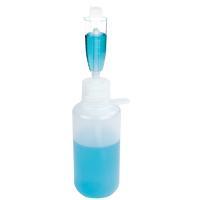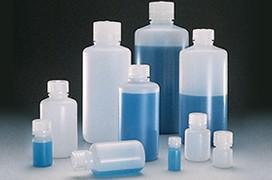The first image is the image on the left, the second image is the image on the right. Considering the images on both sides, is "The left image shows blue liquid in two containers, and the right image includes multiple capped bottles containing liquid." valid? Answer yes or no. Yes. 